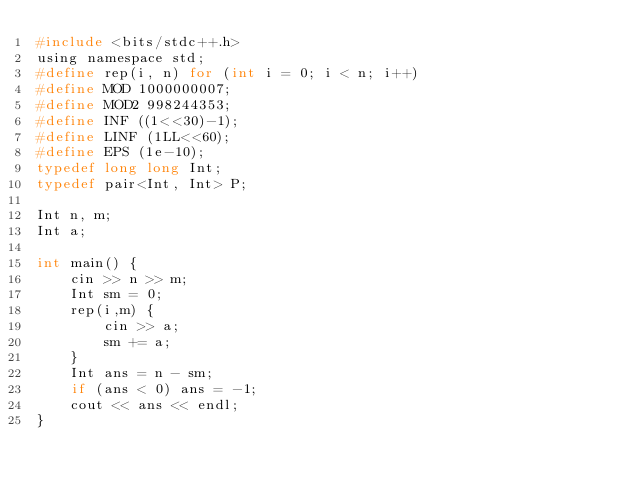Convert code to text. <code><loc_0><loc_0><loc_500><loc_500><_C_>#include <bits/stdc++.h>
using namespace std;
#define rep(i, n) for (int i = 0; i < n; i++)
#define MOD 1000000007;
#define MOD2 998244353;
#define INF ((1<<30)-1);
#define LINF (1LL<<60);
#define EPS (1e-10);
typedef long long Int;
typedef pair<Int, Int> P;

Int n, m;
Int a;

int main() {
    cin >> n >> m;
    Int sm = 0;
    rep(i,m) {
        cin >> a;
        sm += a; 
    }
    Int ans = n - sm;
    if (ans < 0) ans = -1;
    cout << ans << endl;
}</code> 